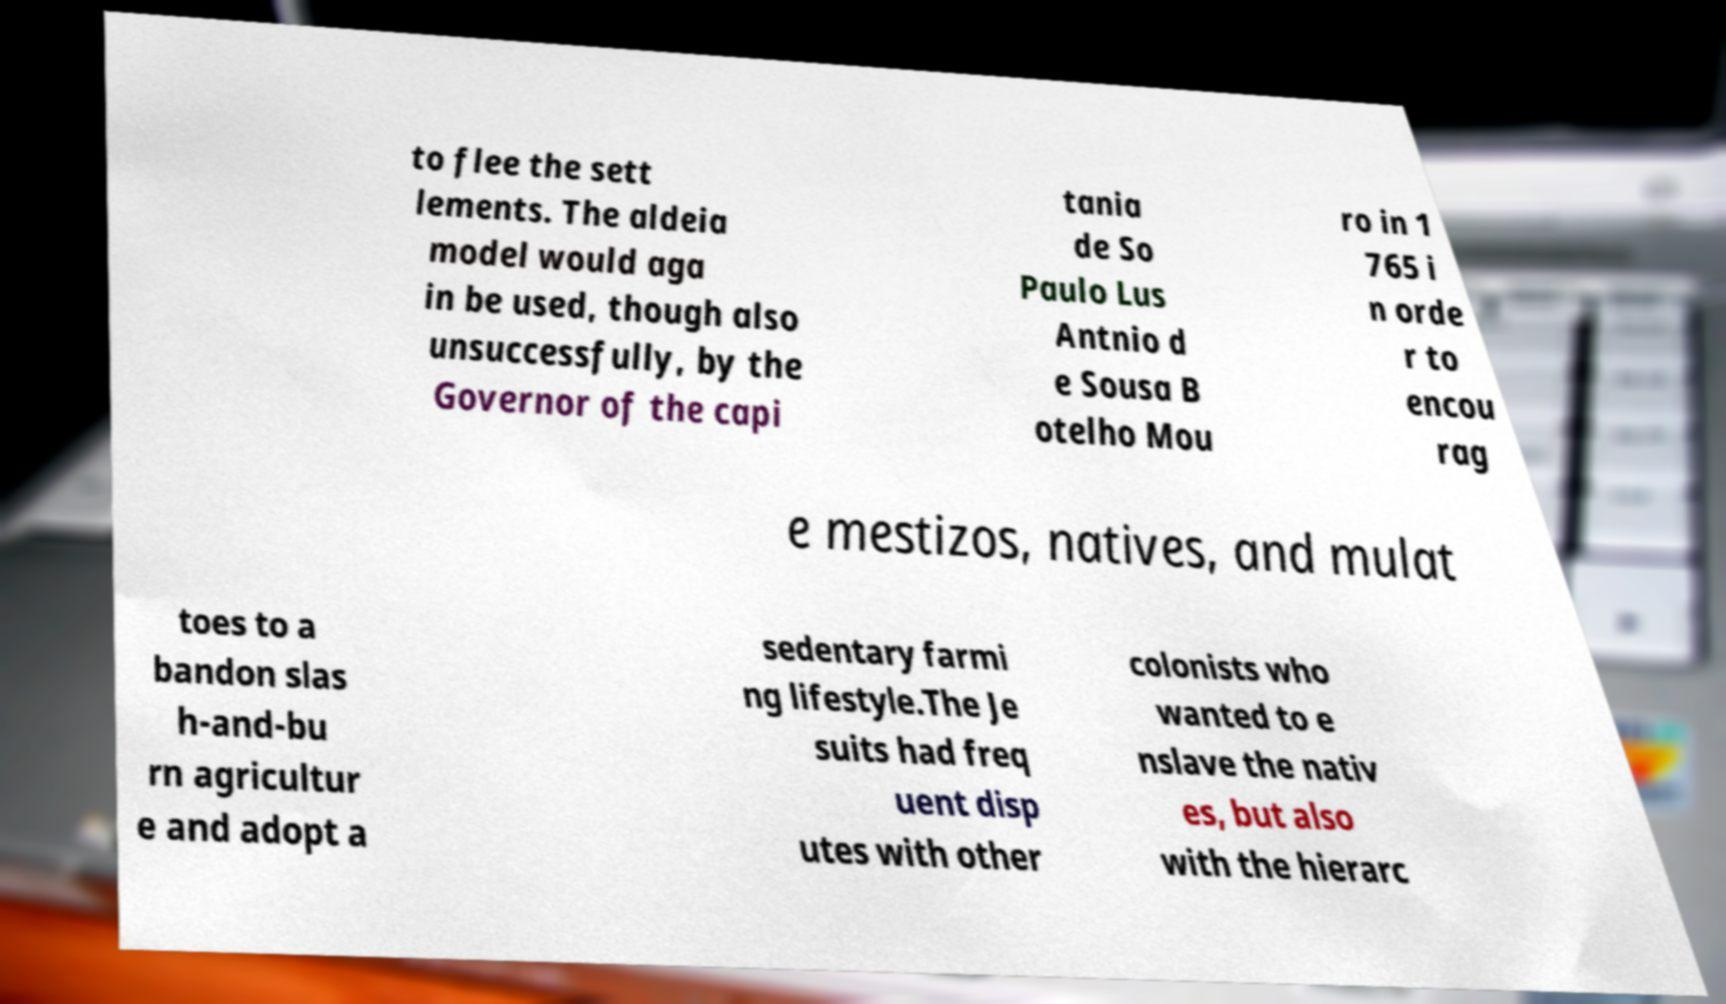There's text embedded in this image that I need extracted. Can you transcribe it verbatim? to flee the sett lements. The aldeia model would aga in be used, though also unsuccessfully, by the Governor of the capi tania de So Paulo Lus Antnio d e Sousa B otelho Mou ro in 1 765 i n orde r to encou rag e mestizos, natives, and mulat toes to a bandon slas h-and-bu rn agricultur e and adopt a sedentary farmi ng lifestyle.The Je suits had freq uent disp utes with other colonists who wanted to e nslave the nativ es, but also with the hierarc 